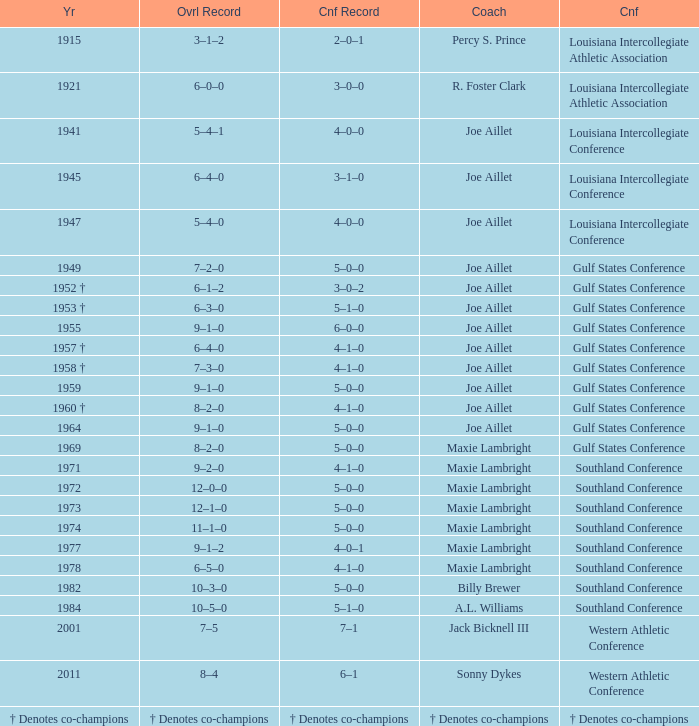I'm looking to parse the entire table for insights. Could you assist me with that? {'header': ['Yr', 'Ovrl Record', 'Cnf Record', 'Coach', 'Cnf'], 'rows': [['1915', '3–1–2', '2–0–1', 'Percy S. Prince', 'Louisiana Intercollegiate Athletic Association'], ['1921', '6–0–0', '3–0–0', 'R. Foster Clark', 'Louisiana Intercollegiate Athletic Association'], ['1941', '5–4–1', '4–0–0', 'Joe Aillet', 'Louisiana Intercollegiate Conference'], ['1945', '6–4–0', '3–1–0', 'Joe Aillet', 'Louisiana Intercollegiate Conference'], ['1947', '5–4–0', '4–0–0', 'Joe Aillet', 'Louisiana Intercollegiate Conference'], ['1949', '7–2–0', '5–0–0', 'Joe Aillet', 'Gulf States Conference'], ['1952 †', '6–1–2', '3–0–2', 'Joe Aillet', 'Gulf States Conference'], ['1953 †', '6–3–0', '5–1–0', 'Joe Aillet', 'Gulf States Conference'], ['1955', '9–1–0', '6–0–0', 'Joe Aillet', 'Gulf States Conference'], ['1957 †', '6–4–0', '4–1–0', 'Joe Aillet', 'Gulf States Conference'], ['1958 †', '7–3–0', '4–1–0', 'Joe Aillet', 'Gulf States Conference'], ['1959', '9–1–0', '5–0–0', 'Joe Aillet', 'Gulf States Conference'], ['1960 †', '8–2–0', '4–1–0', 'Joe Aillet', 'Gulf States Conference'], ['1964', '9–1–0', '5–0–0', 'Joe Aillet', 'Gulf States Conference'], ['1969', '8–2–0', '5–0–0', 'Maxie Lambright', 'Gulf States Conference'], ['1971', '9–2–0', '4–1–0', 'Maxie Lambright', 'Southland Conference'], ['1972', '12–0–0', '5–0–0', 'Maxie Lambright', 'Southland Conference'], ['1973', '12–1–0', '5–0–0', 'Maxie Lambright', 'Southland Conference'], ['1974', '11–1–0', '5–0–0', 'Maxie Lambright', 'Southland Conference'], ['1977', '9–1–2', '4–0–1', 'Maxie Lambright', 'Southland Conference'], ['1978', '6–5–0', '4–1–0', 'Maxie Lambright', 'Southland Conference'], ['1982', '10–3–0', '5–0–0', 'Billy Brewer', 'Southland Conference'], ['1984', '10–5–0', '5–1–0', 'A.L. Williams', 'Southland Conference'], ['2001', '7–5', '7–1', 'Jack Bicknell III', 'Western Athletic Conference'], ['2011', '8–4', '6–1', 'Sonny Dykes', 'Western Athletic Conference'], ['† Denotes co-champions', '† Denotes co-champions', '† Denotes co-champions', '† Denotes co-champions', '† Denotes co-champions']]} Can you provide the conference record for 1971? 4–1–0. 